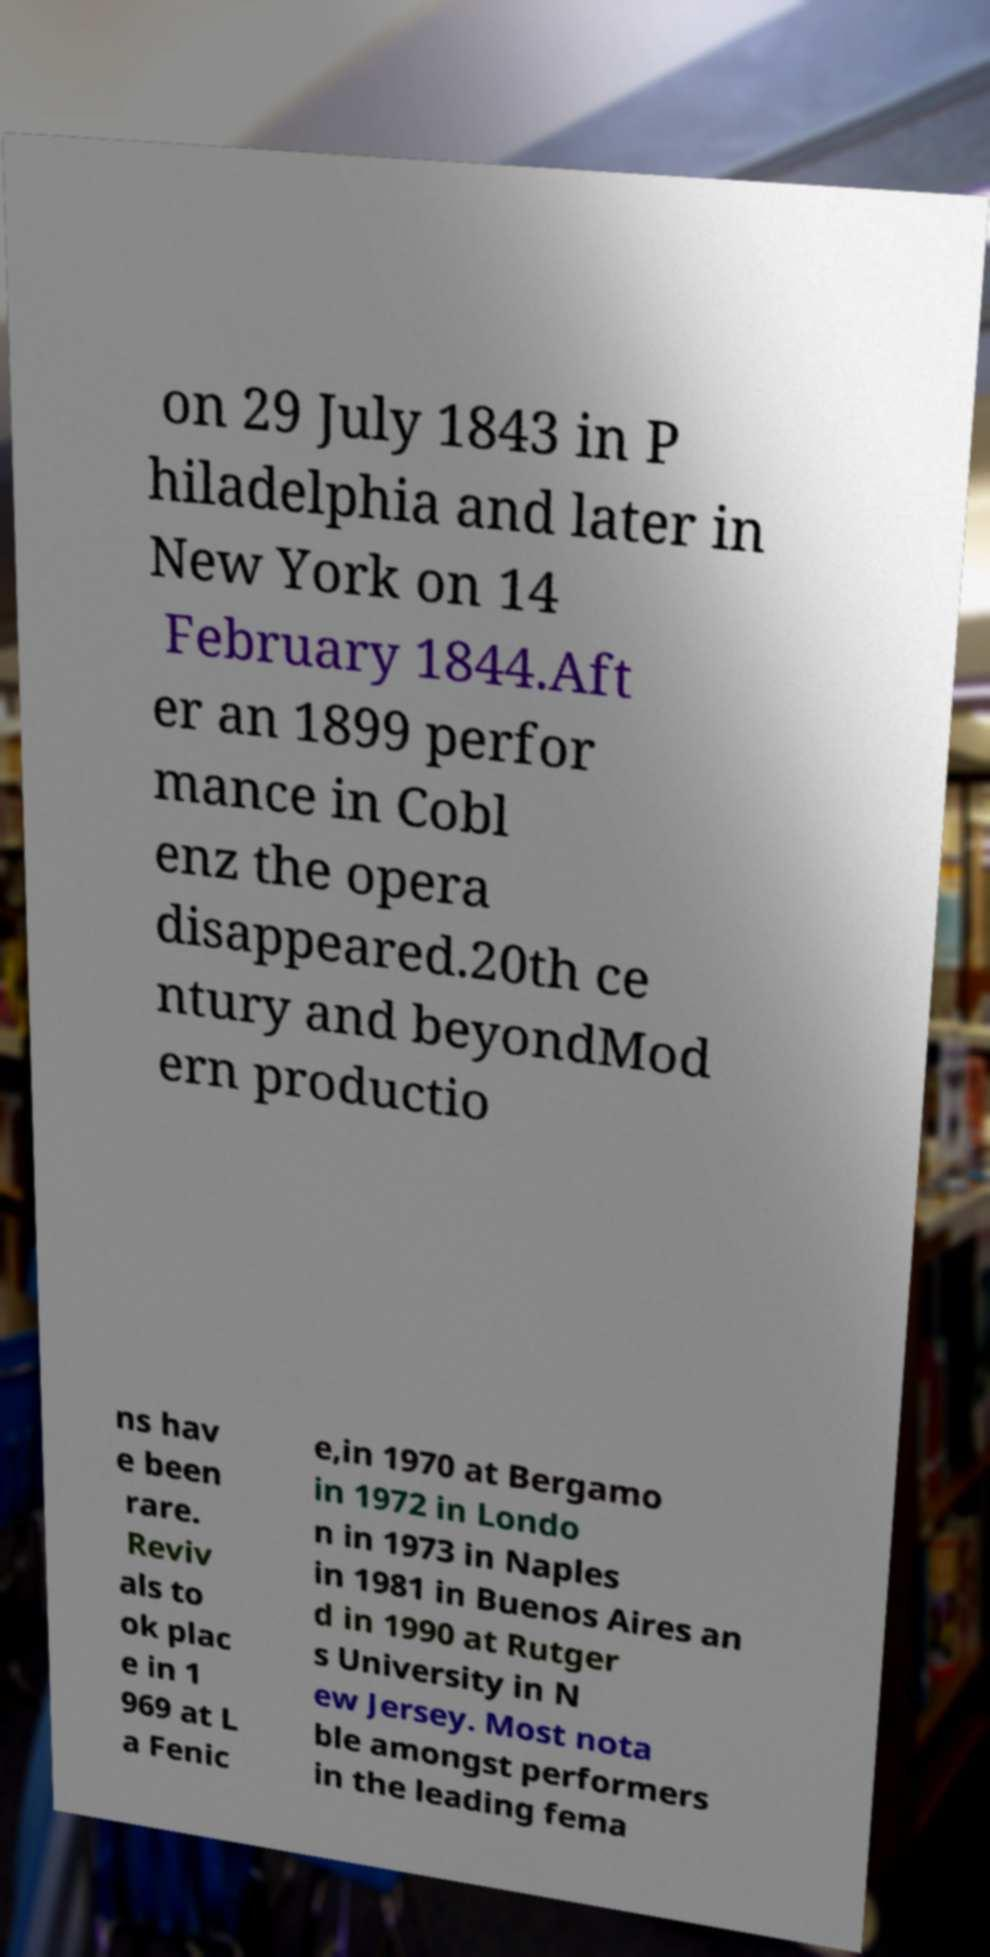What messages or text are displayed in this image? I need them in a readable, typed format. on 29 July 1843 in P hiladelphia and later in New York on 14 February 1844.Aft er an 1899 perfor mance in Cobl enz the opera disappeared.20th ce ntury and beyondMod ern productio ns hav e been rare. Reviv als to ok plac e in 1 969 at L a Fenic e,in 1970 at Bergamo in 1972 in Londo n in 1973 in Naples in 1981 in Buenos Aires an d in 1990 at Rutger s University in N ew Jersey. Most nota ble amongst performers in the leading fema 